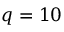<formula> <loc_0><loc_0><loc_500><loc_500>q = 1 0</formula> 